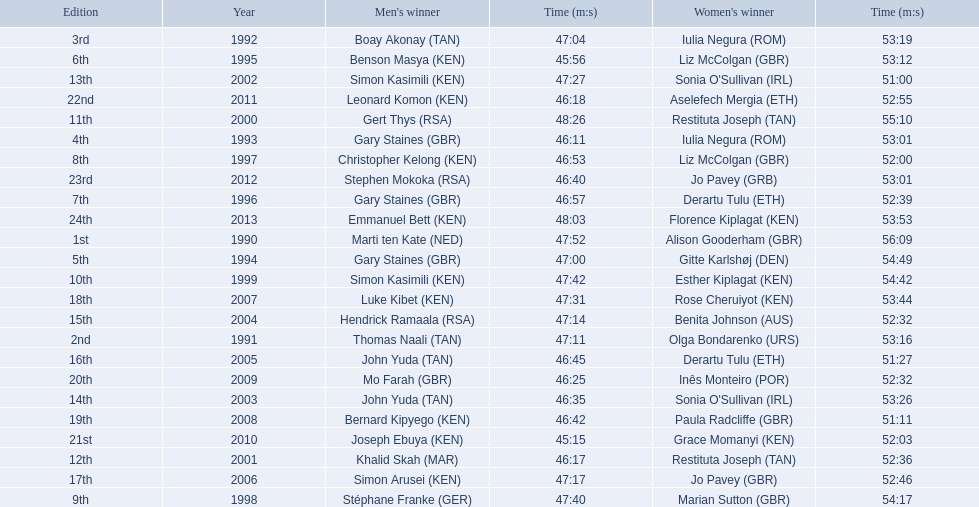Who were all the runners' times between 1990 and 2013? 47:52, 56:09, 47:11, 53:16, 47:04, 53:19, 46:11, 53:01, 47:00, 54:49, 45:56, 53:12, 46:57, 52:39, 46:53, 52:00, 47:40, 54:17, 47:42, 54:42, 48:26, 55:10, 46:17, 52:36, 47:27, 51:00, 46:35, 53:26, 47:14, 52:32, 46:45, 51:27, 47:17, 52:46, 47:31, 53:44, 46:42, 51:11, 46:25, 52:32, 45:15, 52:03, 46:18, 52:55, 46:40, 53:01, 48:03, 53:53. Which was the fastest time? 45:15. Who ran that time? Joseph Ebuya (KEN). 